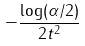Convert formula to latex. <formula><loc_0><loc_0><loc_500><loc_500>- \frac { \log ( \alpha / 2 ) } { 2 t ^ { 2 } }</formula> 